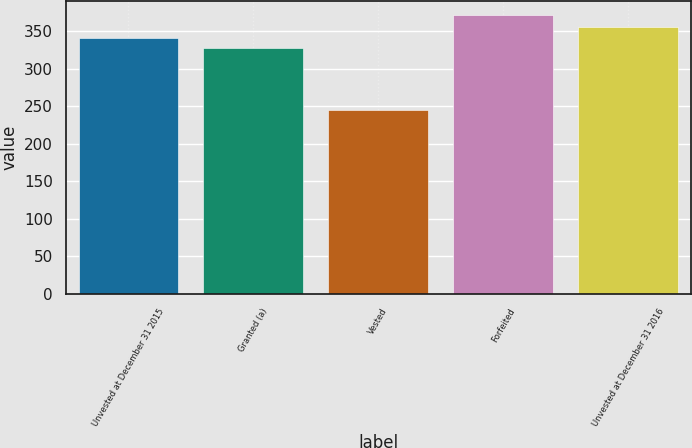Convert chart. <chart><loc_0><loc_0><loc_500><loc_500><bar_chart><fcel>Unvested at December 31 2015<fcel>Granted (a)<fcel>Vested<fcel>Forfeited<fcel>Unvested at December 31 2016<nl><fcel>340.72<fcel>328.03<fcel>244.68<fcel>371.62<fcel>355.6<nl></chart> 